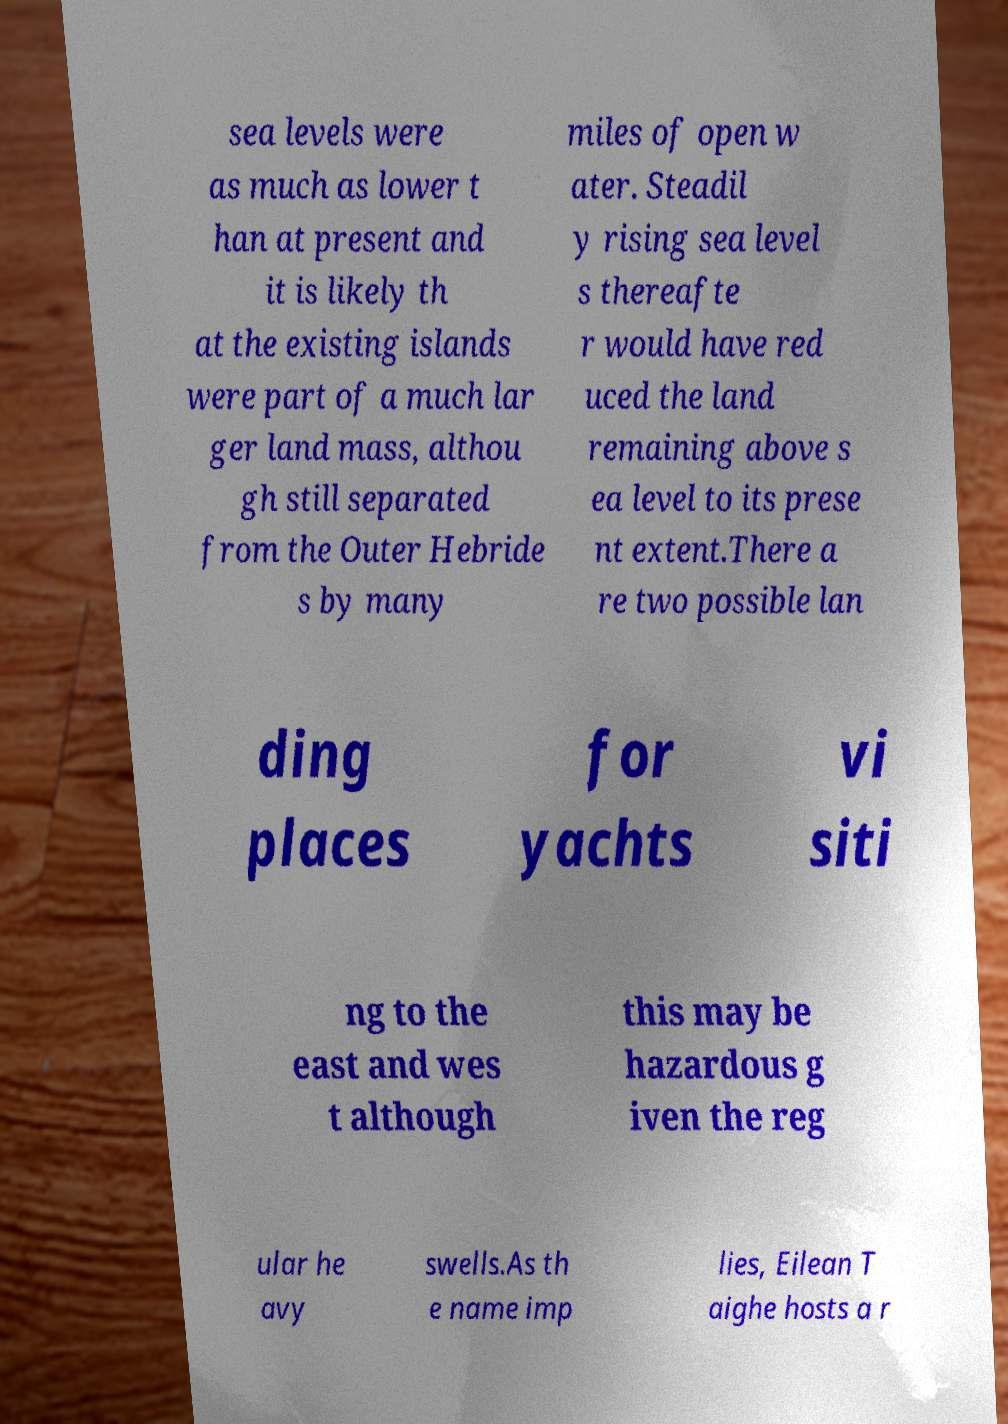Could you assist in decoding the text presented in this image and type it out clearly? sea levels were as much as lower t han at present and it is likely th at the existing islands were part of a much lar ger land mass, althou gh still separated from the Outer Hebride s by many miles of open w ater. Steadil y rising sea level s thereafte r would have red uced the land remaining above s ea level to its prese nt extent.There a re two possible lan ding places for yachts vi siti ng to the east and wes t although this may be hazardous g iven the reg ular he avy swells.As th e name imp lies, Eilean T aighe hosts a r 